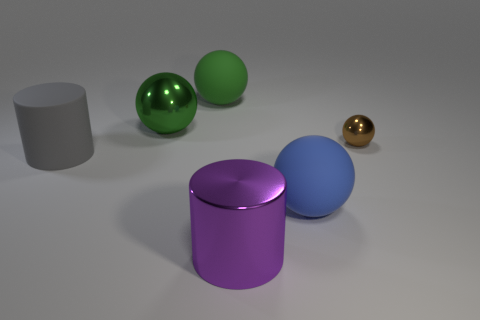Subtract all small spheres. How many spheres are left? 3 Subtract all brown spheres. How many spheres are left? 3 Add 4 blue rubber things. How many objects exist? 10 Subtract 2 cylinders. How many cylinders are left? 0 Subtract all cylinders. How many objects are left? 4 Subtract all blue cylinders. How many brown spheres are left? 1 Subtract all red metallic things. Subtract all small brown metallic spheres. How many objects are left? 5 Add 2 big blue spheres. How many big blue spheres are left? 3 Add 1 purple objects. How many purple objects exist? 2 Subtract 0 red blocks. How many objects are left? 6 